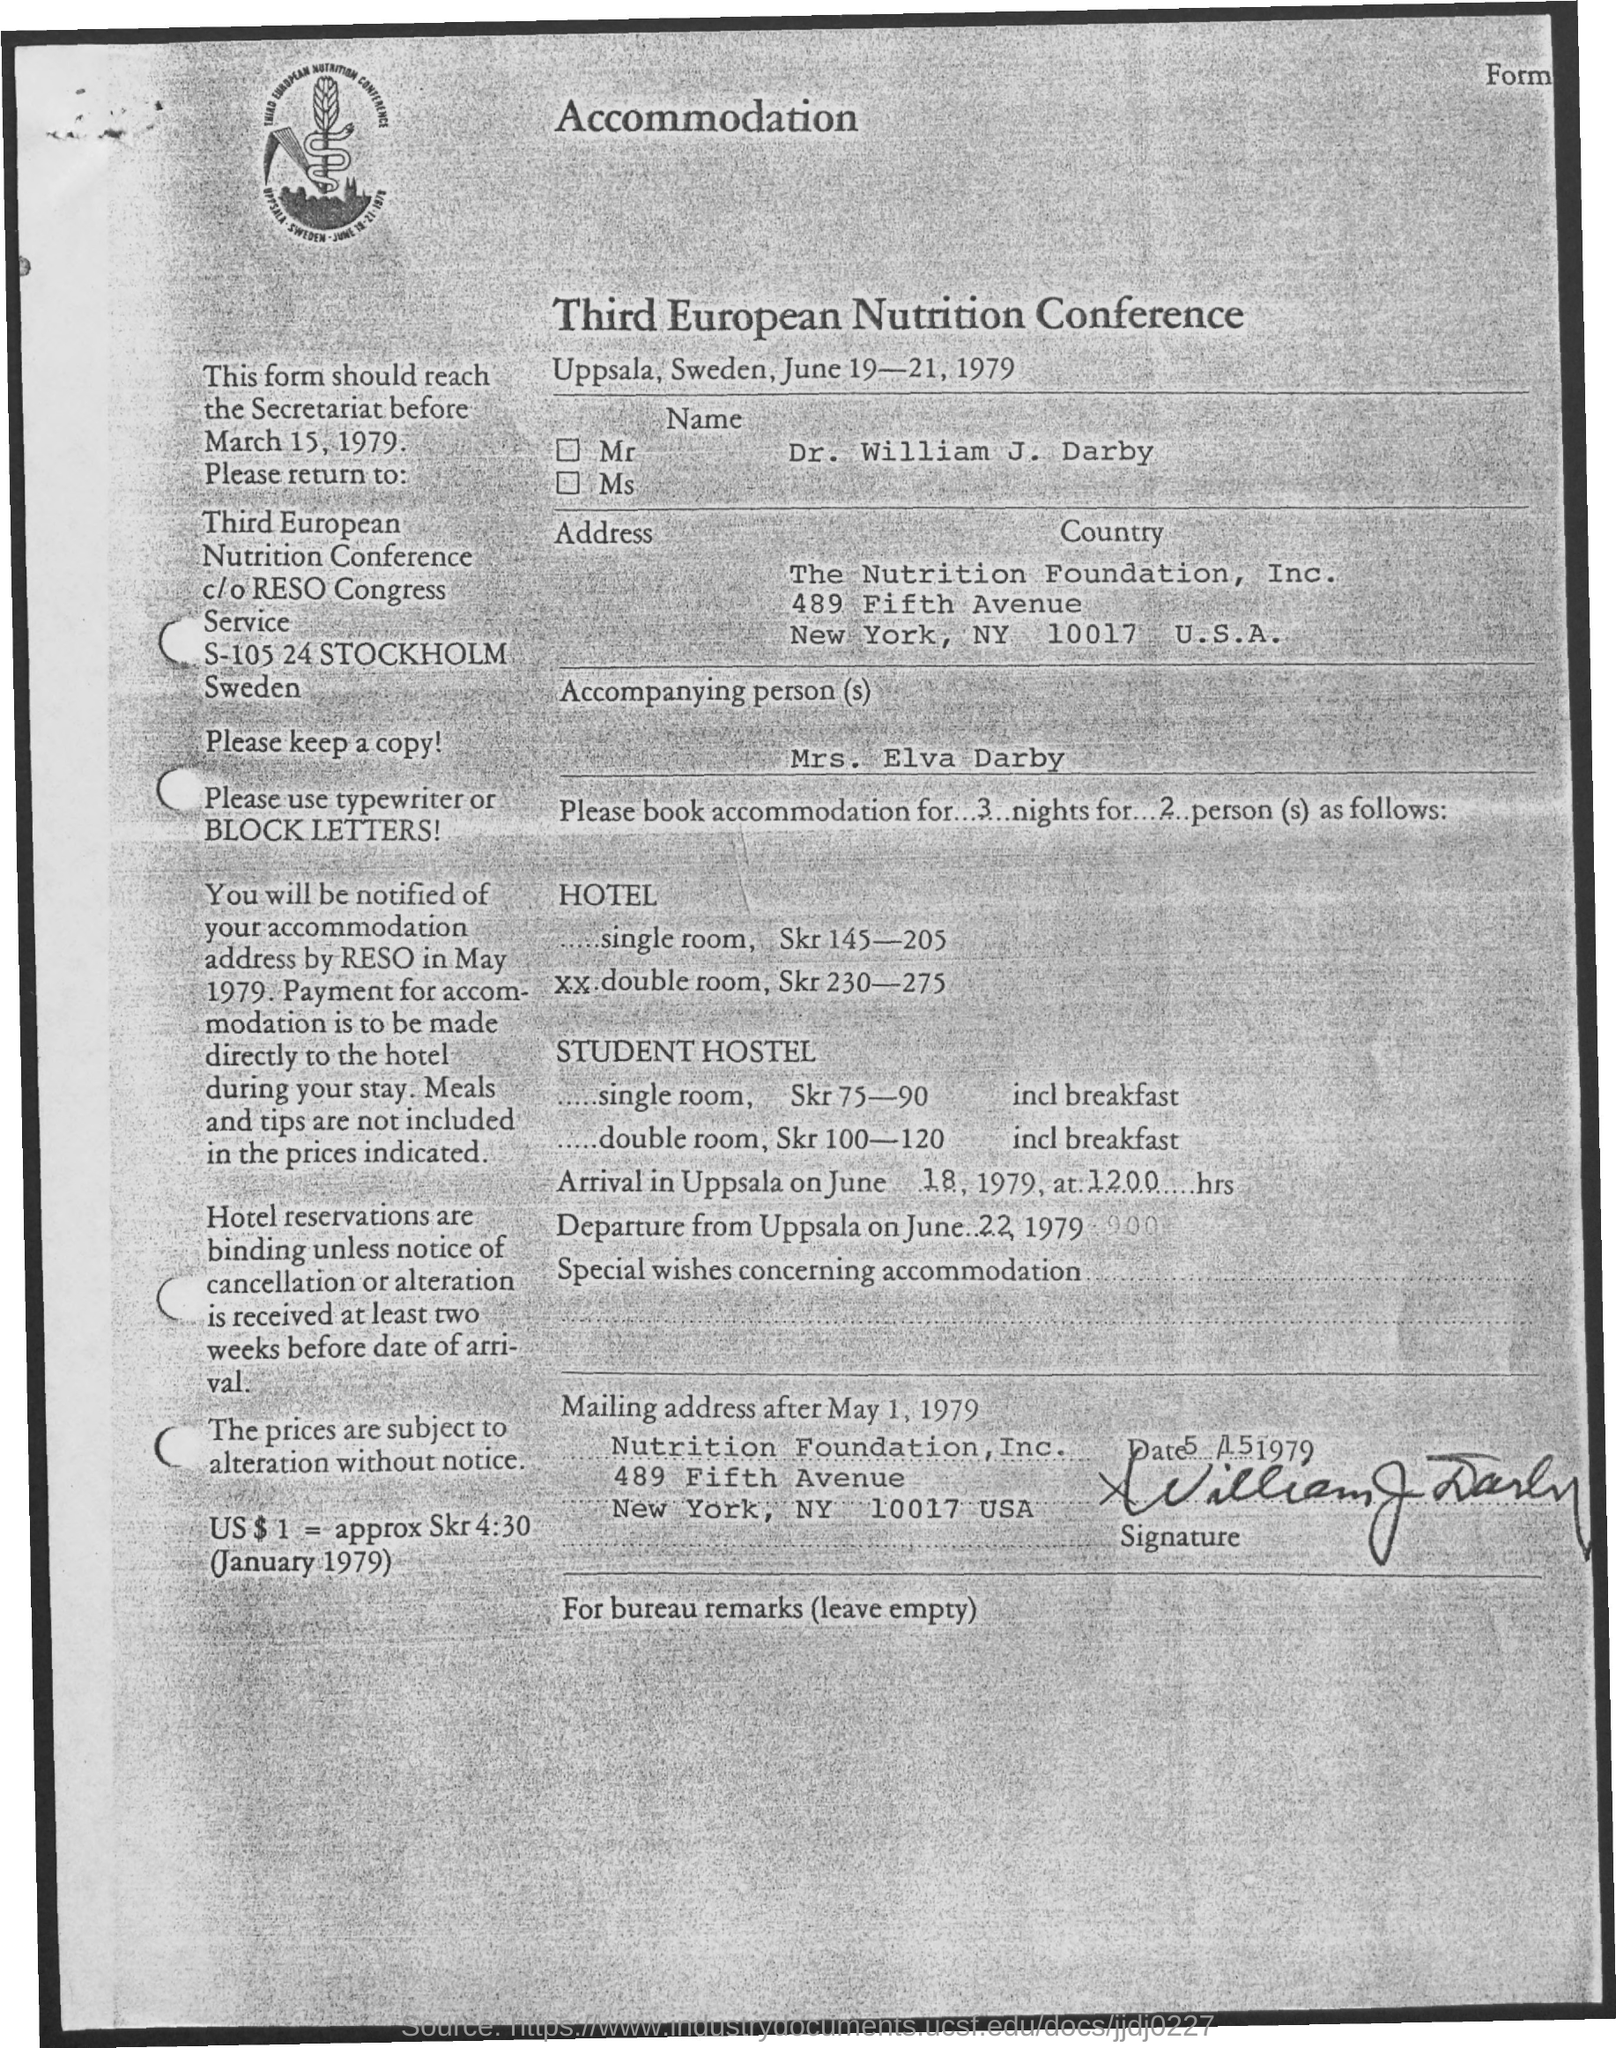Who is the accompanying person
Make the answer very short. Mrs . Elva Darby. This form should reach the secretariat before which date
Make the answer very short. March 15, 1979. What is the name of the person
Your response must be concise. Dr. William J. Darby. Which city is mentioned in the address
Make the answer very short. New york. Third European nutrition Conference is held from which date
Ensure brevity in your answer.  June 19-21 , 1979. 